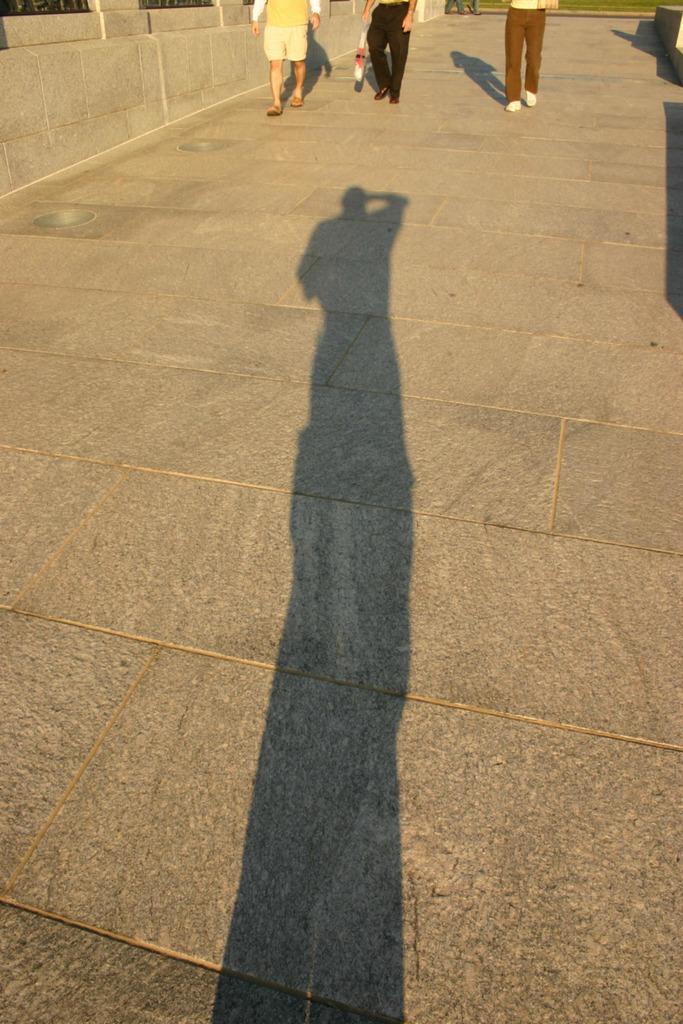Please provide a concise description of this image. In the foreground of this image, on the pavement, there are three persons walking and we can also see the shadow of a person. 